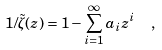Convert formula to latex. <formula><loc_0><loc_0><loc_500><loc_500>1 / \tilde { \zeta } ( z ) = 1 - \sum _ { i = 1 } ^ { \infty } a _ { i } z ^ { i } \ \ ,</formula> 